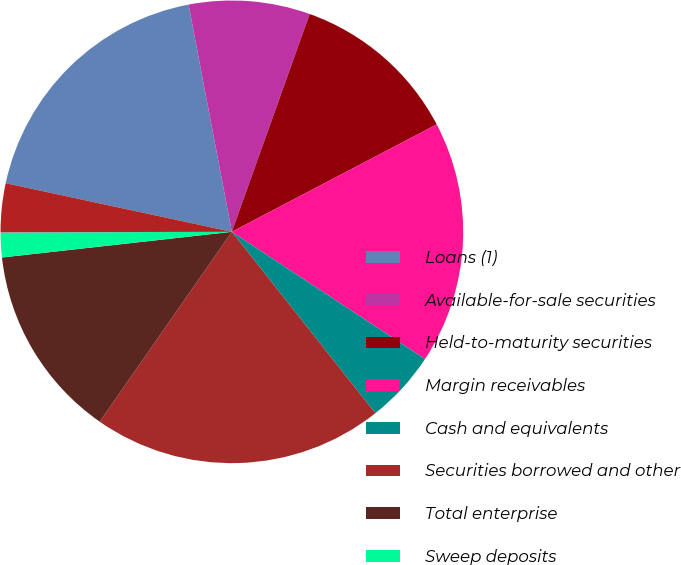<chart> <loc_0><loc_0><loc_500><loc_500><pie_chart><fcel>Loans (1)<fcel>Available-for-sale securities<fcel>Held-to-maturity securities<fcel>Margin receivables<fcel>Cash and equivalents<fcel>Securities borrowed and other<fcel>Total enterprise<fcel>Sweep deposits<fcel>Complete savings deposits<fcel>Customer payables<nl><fcel>18.63%<fcel>8.46%<fcel>11.85%<fcel>16.95%<fcel>5.08%<fcel>20.33%<fcel>13.55%<fcel>1.72%<fcel>0.02%<fcel>3.4%<nl></chart> 